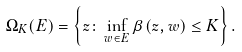<formula> <loc_0><loc_0><loc_500><loc_500>\Omega _ { K } ( E ) = \left \{ z \colon \inf _ { w \in E } \beta ( z , w ) \leq K \right \} .</formula> 